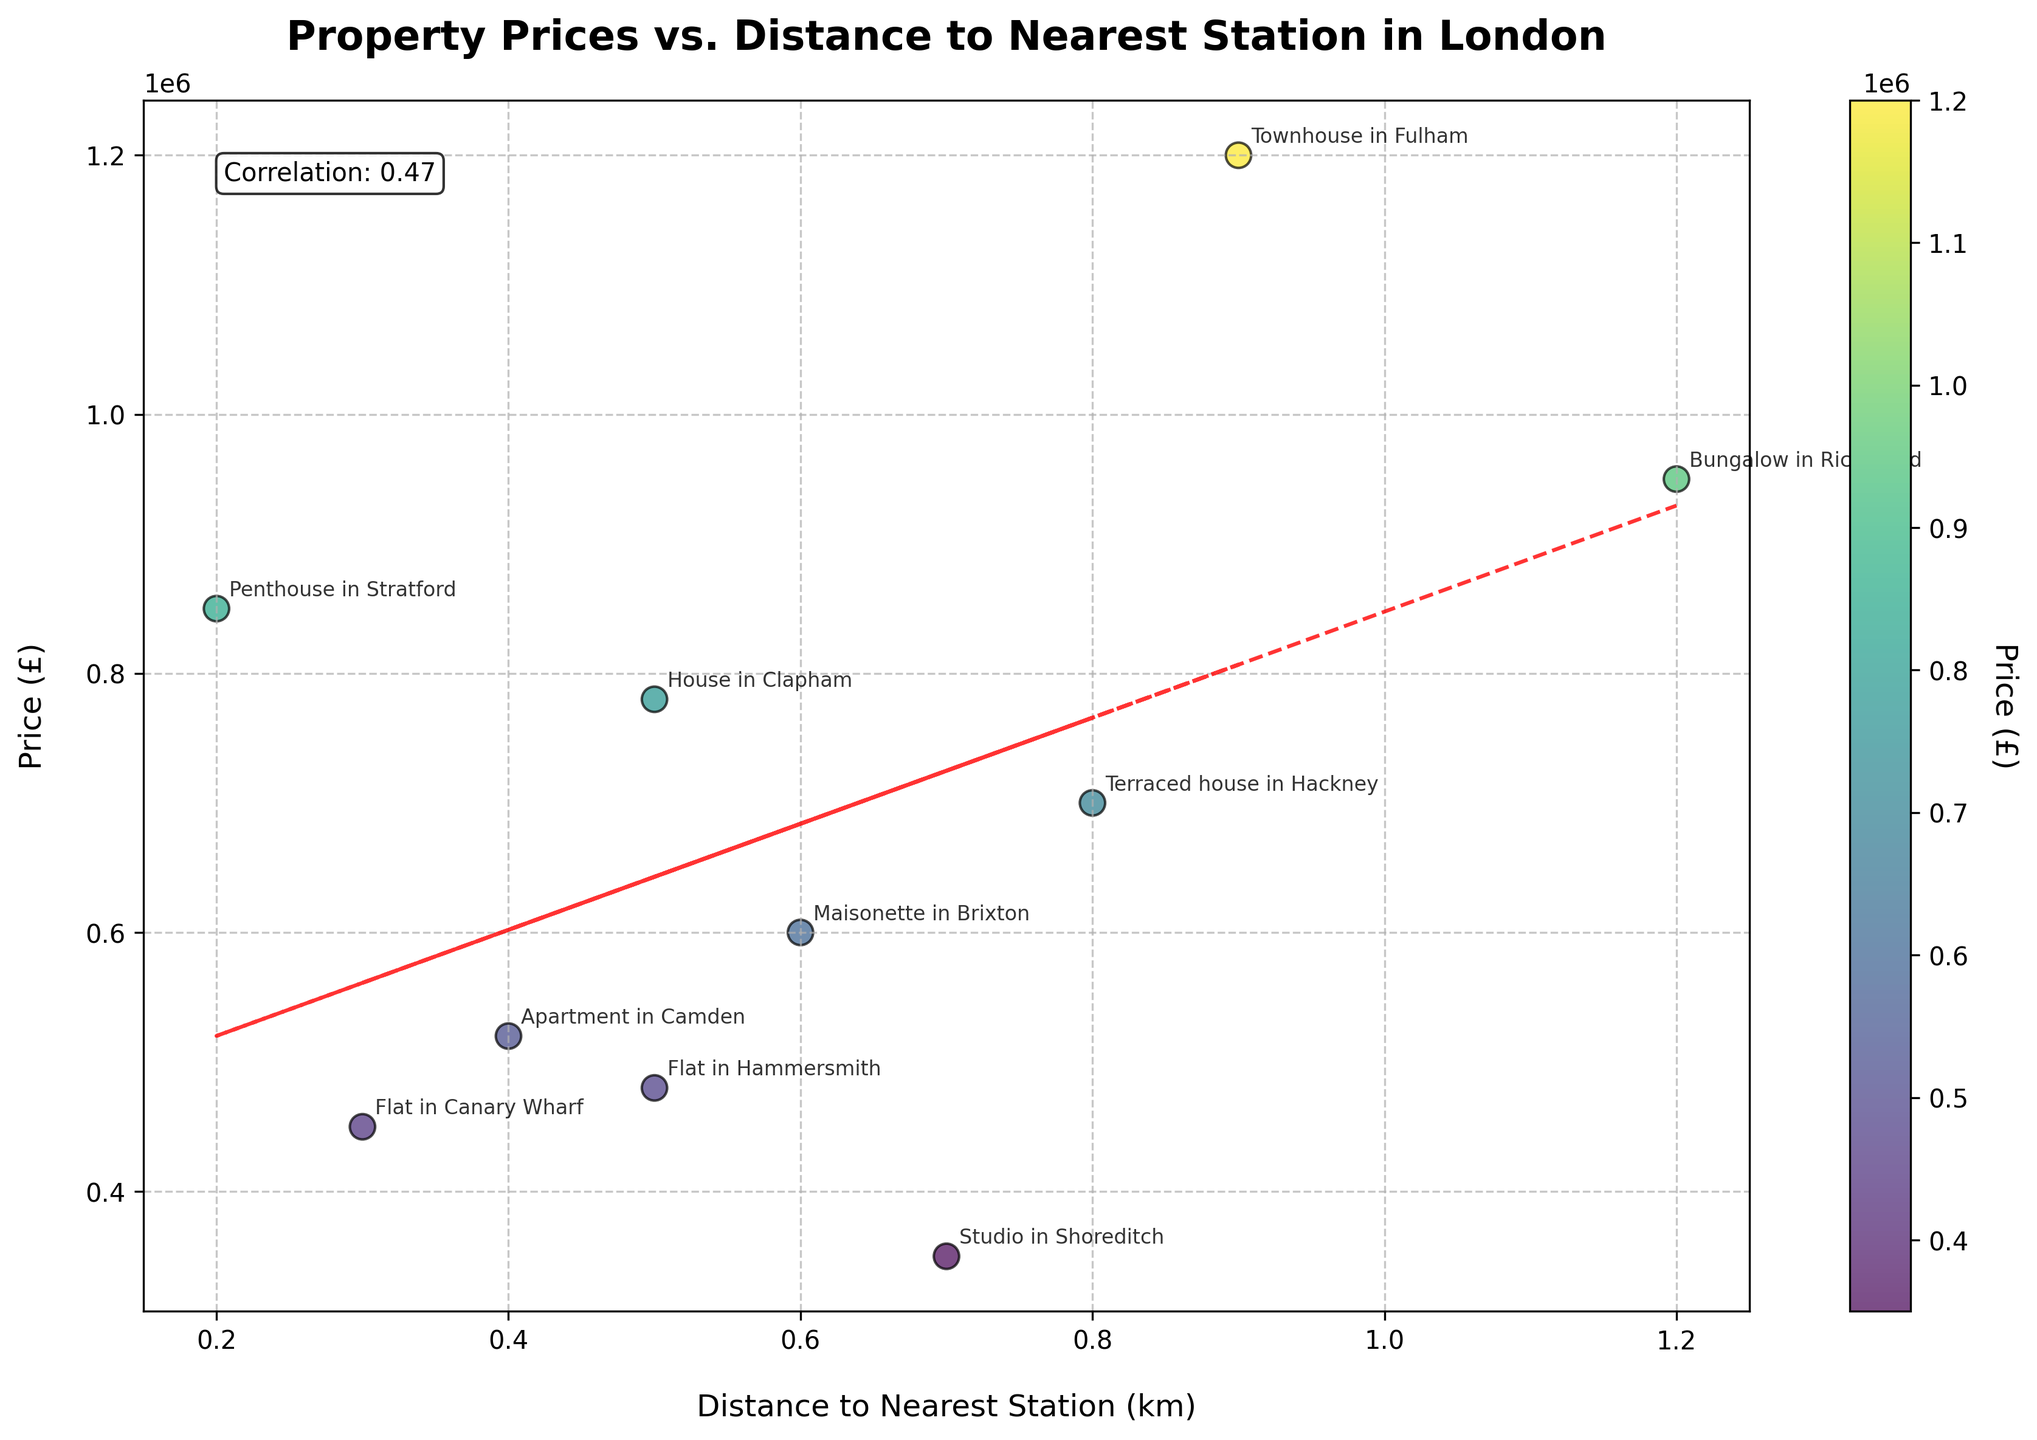What is the title of the plot? The title of the plot is located at the top and reads "Property Prices vs. Distance to Nearest Station in London".
Answer: Property Prices vs. Distance to Nearest Station in London How many data points are shown in the plot? Count the number of dots on the plot. There are 10 data points, each representing a different property in London.
Answer: 10 What is the color range used in the scatter plot, and what does it represent? The color range varies from light to dark, and it represents the property prices (£), as indicated by the color legend bar.
Answer: Property prices (£) Which property is the closest to a public transportation hub? Look for the property with the smallest distance value on the x-axis. The property with the shortest distance (0.2 km) is the Penthouse in Stratford.
Answer: Penthouse in Stratford What is the correlation coefficient between property prices and distance to the nearest station? The correlation coefficient is shown in the text box inside the plot. It is 0.20.
Answer: 0.20 Which property is the most expensive, and what is its price? Find the highest point on the y-axis to determine the most expensive property. The property is the Townhouse in Fulham, and its price is £1,200,000.
Answer: Townhouse in Fulham, £1,200,000 Compare the prices of the properties in Brixton and Hammersmith. Which one is higher? Find the annotated data points for Brixton and Hammersmith and compare their y-values. The property in Brixton is £600,000, and the property in Hammersmith is £480,000. The property in Brixton is higher.
Answer: Brixton What is the trend line's direction in the plot? Observe the red dashed line in the plot, which represents the trend line. It slopes slightly downwards, indicating a negative correlation.
Answer: Downward What is the average price of the properties in the plot? Calculate the sum of all property prices and divide by the number of properties: (450000 + 780000 + 350000 + 1200000 + 520000 + 600000 + 850000 + 700000 + 480000 + 950000)/10 = 683000.
Answer: £683,000 Which property has the greatest distance to the nearest station, and what is that distance? Locate the property that is farthest to the right on the x-axis. It is the Bungalow in Richmond, with a distance of 1.2 km.
Answer: Bungalow in Richmond, 1.2 km 